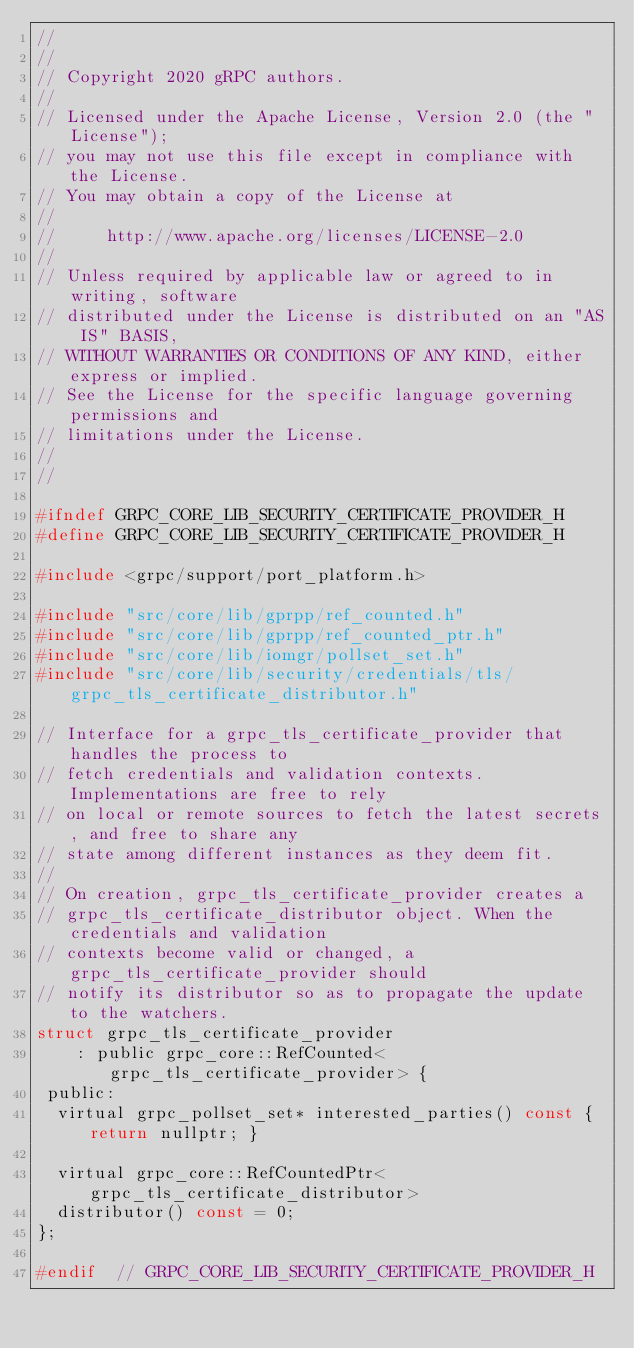<code> <loc_0><loc_0><loc_500><loc_500><_C_>//
//
// Copyright 2020 gRPC authors.
//
// Licensed under the Apache License, Version 2.0 (the "License");
// you may not use this file except in compliance with the License.
// You may obtain a copy of the License at
//
//     http://www.apache.org/licenses/LICENSE-2.0
//
// Unless required by applicable law or agreed to in writing, software
// distributed under the License is distributed on an "AS IS" BASIS,
// WITHOUT WARRANTIES OR CONDITIONS OF ANY KIND, either express or implied.
// See the License for the specific language governing permissions and
// limitations under the License.
//
//

#ifndef GRPC_CORE_LIB_SECURITY_CERTIFICATE_PROVIDER_H
#define GRPC_CORE_LIB_SECURITY_CERTIFICATE_PROVIDER_H

#include <grpc/support/port_platform.h>

#include "src/core/lib/gprpp/ref_counted.h"
#include "src/core/lib/gprpp/ref_counted_ptr.h"
#include "src/core/lib/iomgr/pollset_set.h"
#include "src/core/lib/security/credentials/tls/grpc_tls_certificate_distributor.h"

// Interface for a grpc_tls_certificate_provider that handles the process to
// fetch credentials and validation contexts. Implementations are free to rely
// on local or remote sources to fetch the latest secrets, and free to share any
// state among different instances as they deem fit.
//
// On creation, grpc_tls_certificate_provider creates a
// grpc_tls_certificate_distributor object. When the credentials and validation
// contexts become valid or changed, a grpc_tls_certificate_provider should
// notify its distributor so as to propagate the update to the watchers.
struct grpc_tls_certificate_provider
    : public grpc_core::RefCounted<grpc_tls_certificate_provider> {
 public:
  virtual grpc_pollset_set* interested_parties() const { return nullptr; }

  virtual grpc_core::RefCountedPtr<grpc_tls_certificate_distributor>
  distributor() const = 0;
};

#endif  // GRPC_CORE_LIB_SECURITY_CERTIFICATE_PROVIDER_H
</code> 